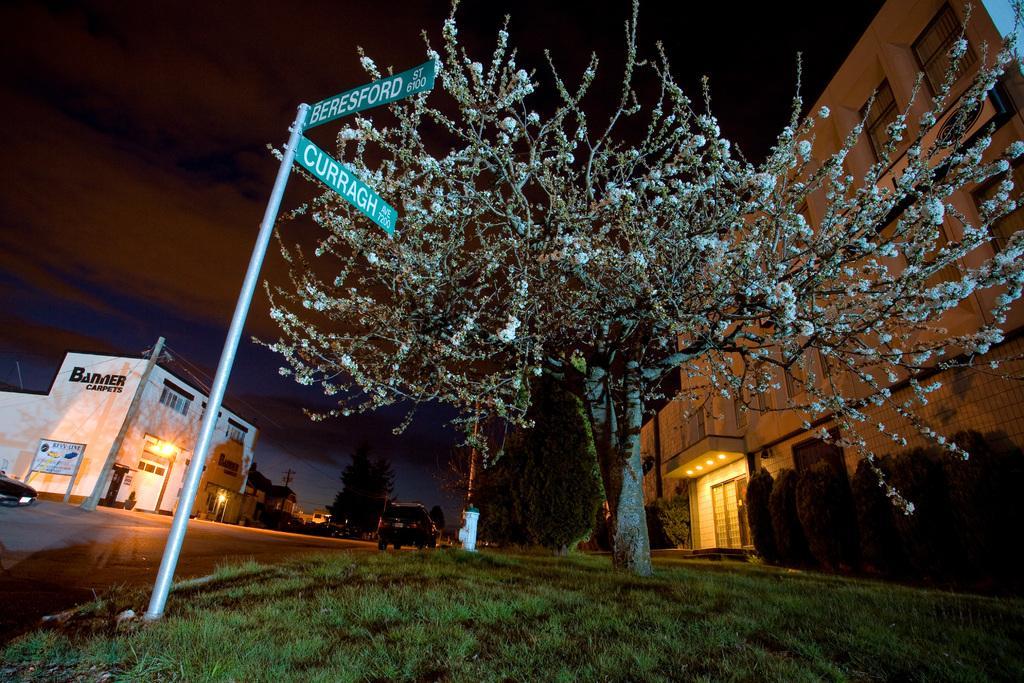Please provide a concise description of this image. In this image, we can see trees, buildings, lights, shrubs, poles along with wires, boards and we can see vehicles on the road. At the top, there is sky. 